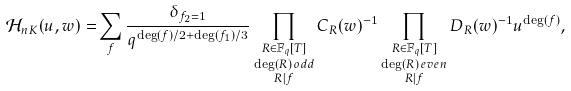<formula> <loc_0><loc_0><loc_500><loc_500>\mathcal { H } _ { n K } ( u , w ) = & \sum _ { f } \frac { \delta _ { f _ { 2 } = 1 } } { q ^ { \deg ( f ) / 2 + \deg ( f _ { 1 } ) / 3 } } \prod _ { \substack { R \in \mathbb { F } _ { q } [ T ] \\ \deg ( R ) \, o d d \\ R | f } } C _ { R } ( w ) ^ { - 1 } \prod _ { \substack { R \in \mathbb { F } _ { q } [ T ] \\ \deg ( R ) \, e v e n \\ R | f } } D _ { R } ( w ) ^ { - 1 } u ^ { \deg ( f ) } ,</formula> 